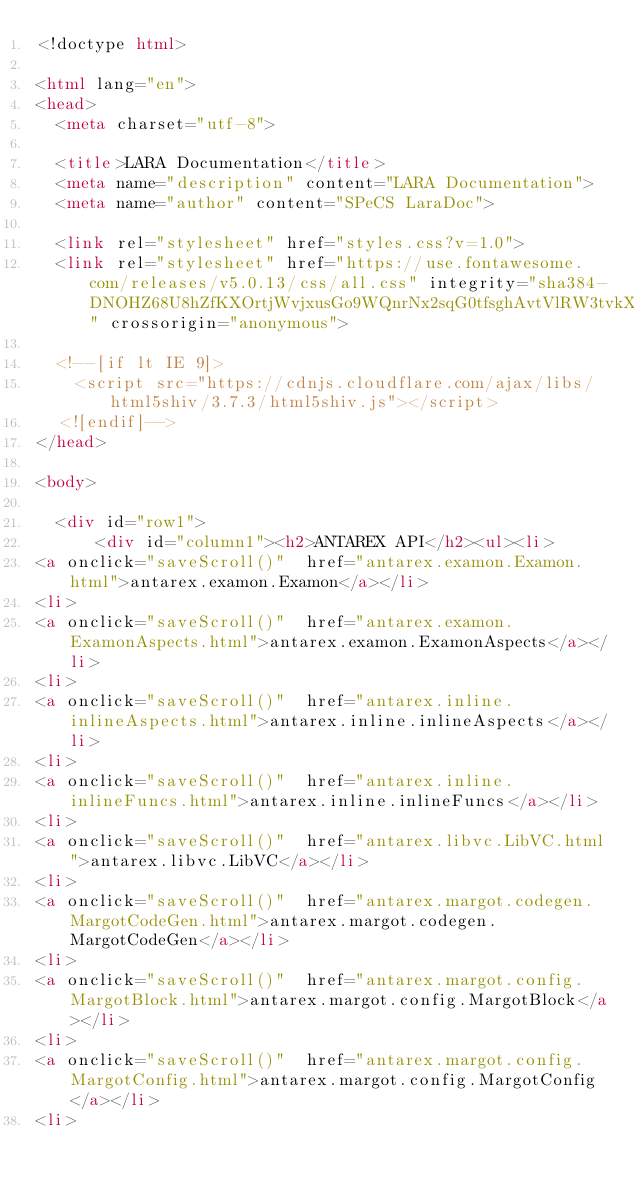Convert code to text. <code><loc_0><loc_0><loc_500><loc_500><_HTML_><!doctype html>

<html lang="en">
<head>
  <meta charset="utf-8">

  <title>LARA Documentation</title>
  <meta name="description" content="LARA Documentation">
  <meta name="author" content="SPeCS LaraDoc">

  <link rel="stylesheet" href="styles.css?v=1.0">
  <link rel="stylesheet" href="https://use.fontawesome.com/releases/v5.0.13/css/all.css" integrity="sha384-DNOHZ68U8hZfKXOrtjWvjxusGo9WQnrNx2sqG0tfsghAvtVlRW3tvkXWZh58N9jp" crossorigin="anonymous">

  <!--[if lt IE 9]>
    <script src="https://cdnjs.cloudflare.com/ajax/libs/html5shiv/3.7.3/html5shiv.js"></script>
  <![endif]-->
</head>

<body>

	<div id="row1">
    	<div id="column1"><h2>ANTAREX API</h2><ul><li>
<a onclick="saveScroll()"  href="antarex.examon.Examon.html">antarex.examon.Examon</a></li>
<li>
<a onclick="saveScroll()"  href="antarex.examon.ExamonAspects.html">antarex.examon.ExamonAspects</a></li>
<li>
<a onclick="saveScroll()"  href="antarex.inline.inlineAspects.html">antarex.inline.inlineAspects</a></li>
<li>
<a onclick="saveScroll()"  href="antarex.inline.inlineFuncs.html">antarex.inline.inlineFuncs</a></li>
<li>
<a onclick="saveScroll()"  href="antarex.libvc.LibVC.html">antarex.libvc.LibVC</a></li>
<li>
<a onclick="saveScroll()"  href="antarex.margot.codegen.MargotCodeGen.html">antarex.margot.codegen.MargotCodeGen</a></li>
<li>
<a onclick="saveScroll()"  href="antarex.margot.config.MargotBlock.html">antarex.margot.config.MargotBlock</a></li>
<li>
<a onclick="saveScroll()"  href="antarex.margot.config.MargotConfig.html">antarex.margot.config.MargotConfig</a></li>
<li></code> 